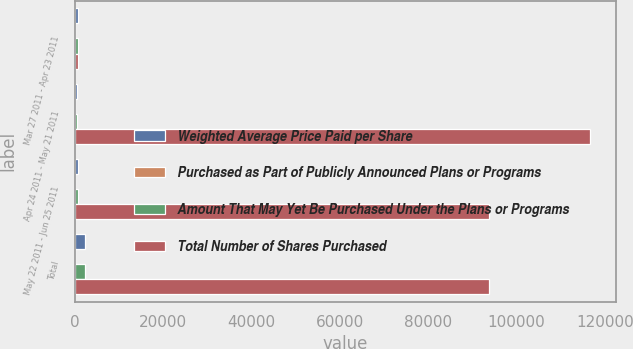<chart> <loc_0><loc_0><loc_500><loc_500><stacked_bar_chart><ecel><fcel>Mar 27 2011 - Apr 23 2011<fcel>Apr 24 2011 - May 21 2011<fcel>May 22 2011 - Jun 25 2011<fcel>Total<nl><fcel>Weighted Average Price Paid per Share<fcel>725<fcel>660<fcel>890<fcel>2275<nl><fcel>Purchased as Part of Publicly Announced Plans or Programs<fcel>25.24<fcel>26.94<fcel>25.77<fcel>25.94<nl><fcel>Amount That May Yet Be Purchased Under the Plans or Programs<fcel>725<fcel>660<fcel>890<fcel>2275<nl><fcel>Total Number of Shares Purchased<fcel>725<fcel>116723<fcel>93791<fcel>93791<nl></chart> 